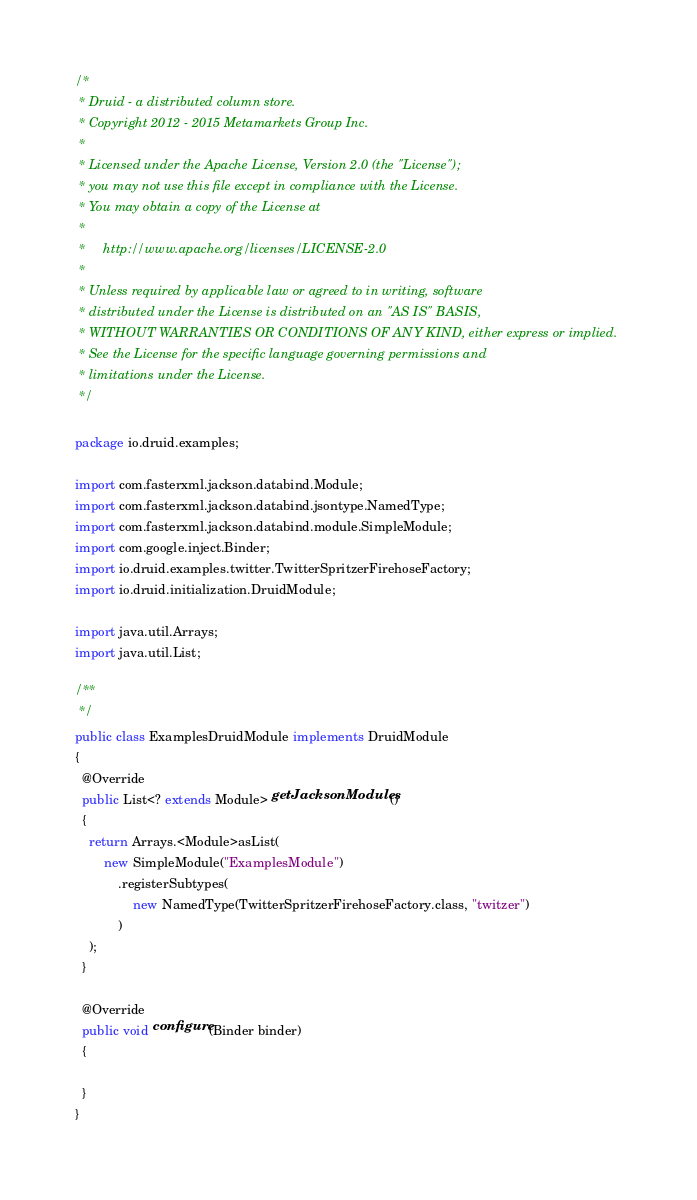Convert code to text. <code><loc_0><loc_0><loc_500><loc_500><_Java_>/*
 * Druid - a distributed column store.
 * Copyright 2012 - 2015 Metamarkets Group Inc.
 *
 * Licensed under the Apache License, Version 2.0 (the "License");
 * you may not use this file except in compliance with the License.
 * You may obtain a copy of the License at
 *
 *     http://www.apache.org/licenses/LICENSE-2.0
 *
 * Unless required by applicable law or agreed to in writing, software
 * distributed under the License is distributed on an "AS IS" BASIS,
 * WITHOUT WARRANTIES OR CONDITIONS OF ANY KIND, either express or implied.
 * See the License for the specific language governing permissions and
 * limitations under the License.
 */

package io.druid.examples;

import com.fasterxml.jackson.databind.Module;
import com.fasterxml.jackson.databind.jsontype.NamedType;
import com.fasterxml.jackson.databind.module.SimpleModule;
import com.google.inject.Binder;
import io.druid.examples.twitter.TwitterSpritzerFirehoseFactory;
import io.druid.initialization.DruidModule;

import java.util.Arrays;
import java.util.List;

/**
 */
public class ExamplesDruidModule implements DruidModule
{
  @Override
  public List<? extends Module> getJacksonModules()
  {
    return Arrays.<Module>asList(
        new SimpleModule("ExamplesModule")
            .registerSubtypes(
                new NamedType(TwitterSpritzerFirehoseFactory.class, "twitzer")
            )
    );
  }

  @Override
  public void configure(Binder binder)
  {

  }
}
</code> 